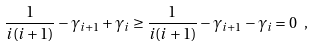Convert formula to latex. <formula><loc_0><loc_0><loc_500><loc_500>\frac { 1 } { i ( i + 1 ) } - \gamma _ { i + 1 } + \gamma _ { i } \geq \frac { 1 } { i ( i + 1 ) } - \gamma _ { i + 1 } - \gamma _ { i } = 0 \ ,</formula> 